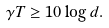<formula> <loc_0><loc_0><loc_500><loc_500>\gamma T \geq 1 0 \log d .</formula> 